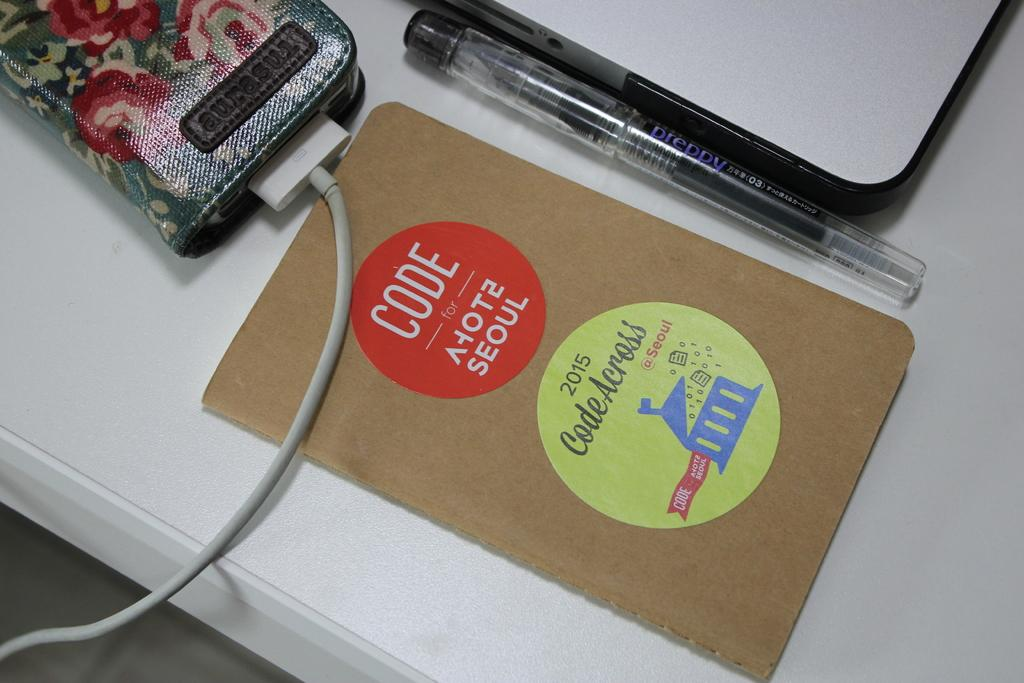What is the main object in the image? There is a table in the image. What is placed on the table? A card, a pen, two devices, and a connector are placed on the table. What is written on the card? There is text on the card. How many devices are present on the table? Two devices are placed on the table. How much change is on the table in the image? There is no mention of change in the image; it only shows a table with a card, a pen, two devices, and a connector. 